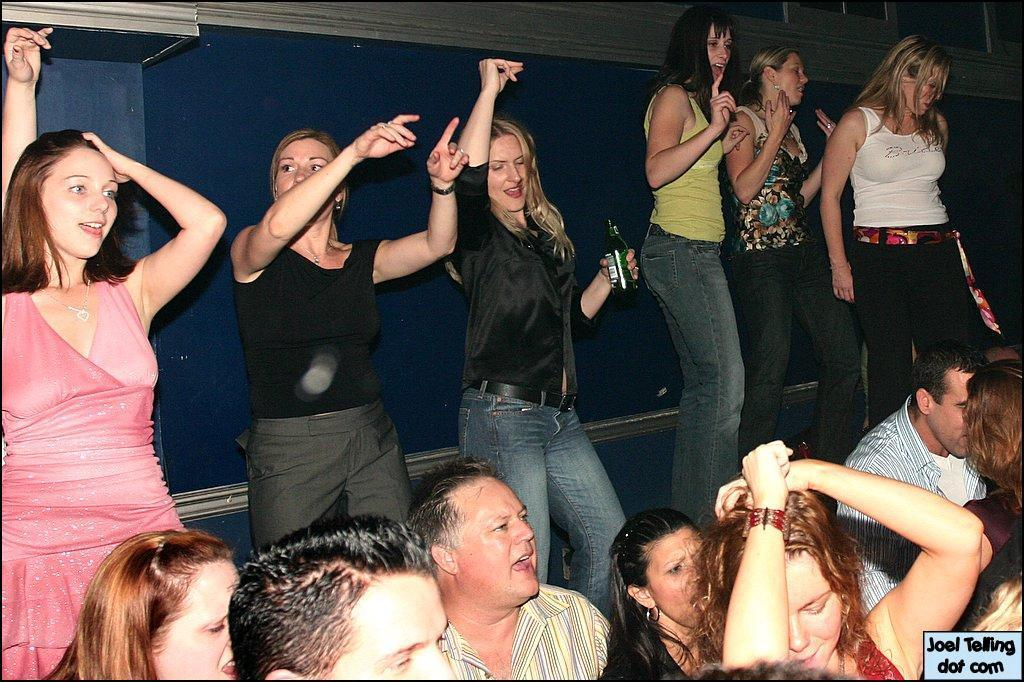What is the main subject of the image? The main subject of the image is a group of people. What are some of the people in the image doing? Some people are standing, and some people are smiling. Can you describe what the woman in the image is holding? The woman is holding a bottle. What can be seen in the background of the image? There is a wall in the background of the image. What type of owl can be seen sitting on the letter in the image? There is no owl or letter present in the image. What station is visible in the background of the image? There is no station visible in the background of the image; it features a wall. 